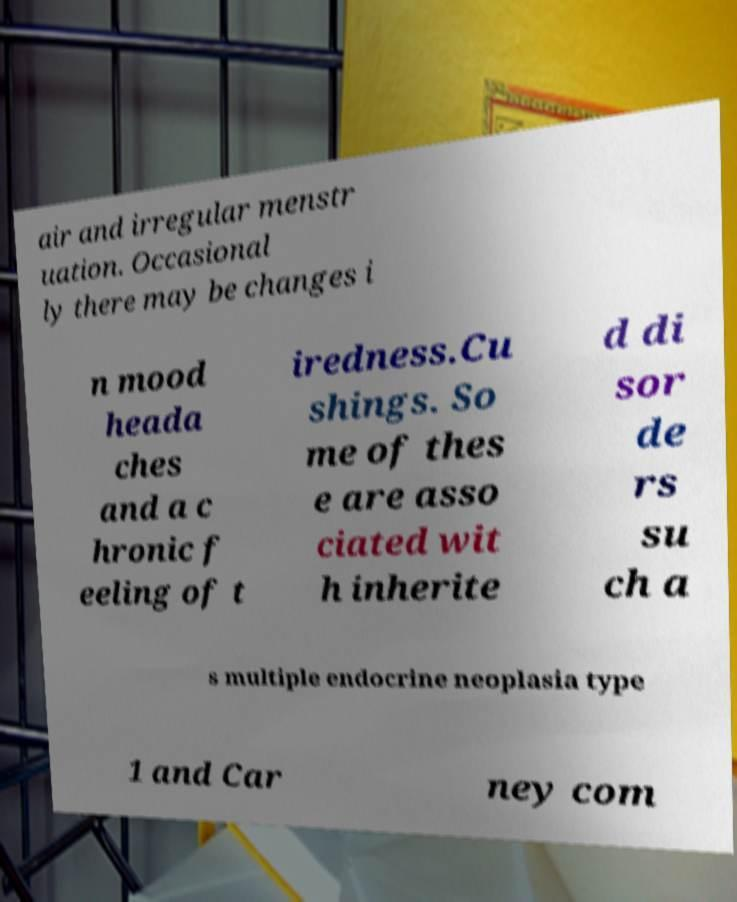Can you accurately transcribe the text from the provided image for me? air and irregular menstr uation. Occasional ly there may be changes i n mood heada ches and a c hronic f eeling of t iredness.Cu shings. So me of thes e are asso ciated wit h inherite d di sor de rs su ch a s multiple endocrine neoplasia type 1 and Car ney com 